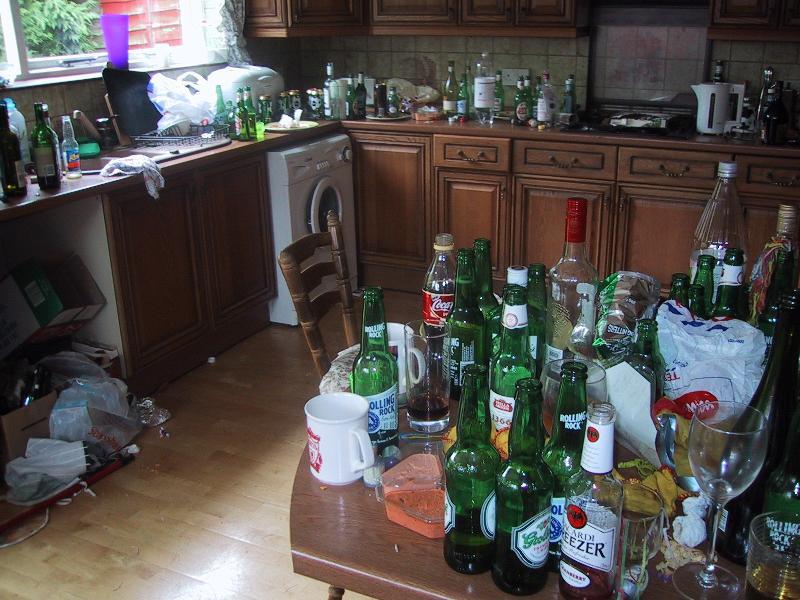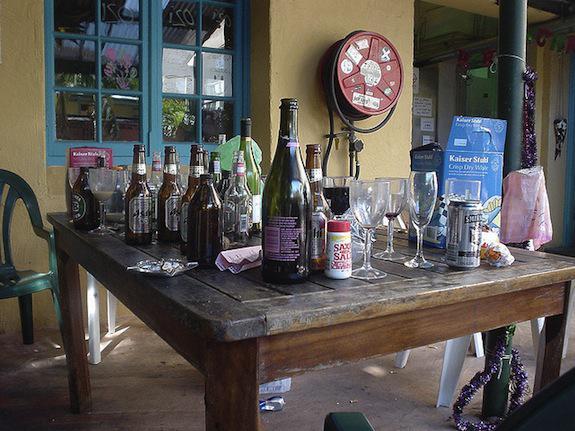The first image is the image on the left, the second image is the image on the right. Evaluate the accuracy of this statement regarding the images: "There is sun coming in through the window in the left image.". Is it true? Answer yes or no. Yes. The first image is the image on the left, the second image is the image on the right. Considering the images on both sides, is "There is one brown table outside with at least 10 open bottles." valid? Answer yes or no. Yes. 